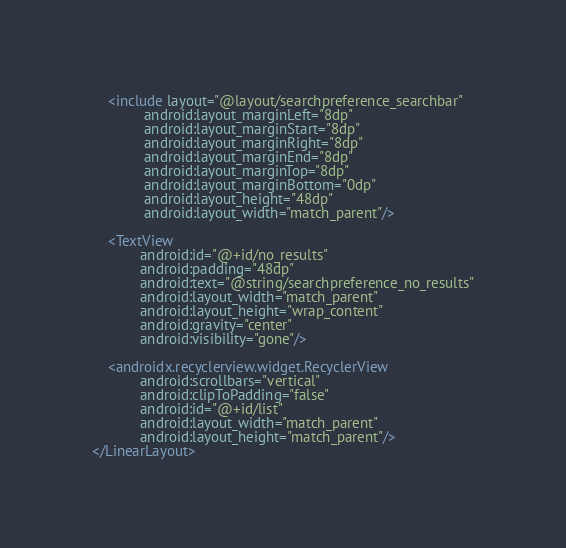<code> <loc_0><loc_0><loc_500><loc_500><_XML_>
    <include layout="@layout/searchpreference_searchbar"
             android:layout_marginLeft="8dp"
             android:layout_marginStart="8dp"
             android:layout_marginRight="8dp"
             android:layout_marginEnd="8dp"
             android:layout_marginTop="8dp"
             android:layout_marginBottom="0dp"
             android:layout_height="48dp"
             android:layout_width="match_parent"/>

    <TextView
            android:id="@+id/no_results"
            android:padding="48dp"
            android:text="@string/searchpreference_no_results"
            android:layout_width="match_parent"
            android:layout_height="wrap_content"
            android:gravity="center"
            android:visibility="gone"/>

    <androidx.recyclerview.widget.RecyclerView
            android:scrollbars="vertical"
            android:clipToPadding="false"
            android:id="@+id/list"
            android:layout_width="match_parent"
            android:layout_height="match_parent"/>
</LinearLayout>
</code> 